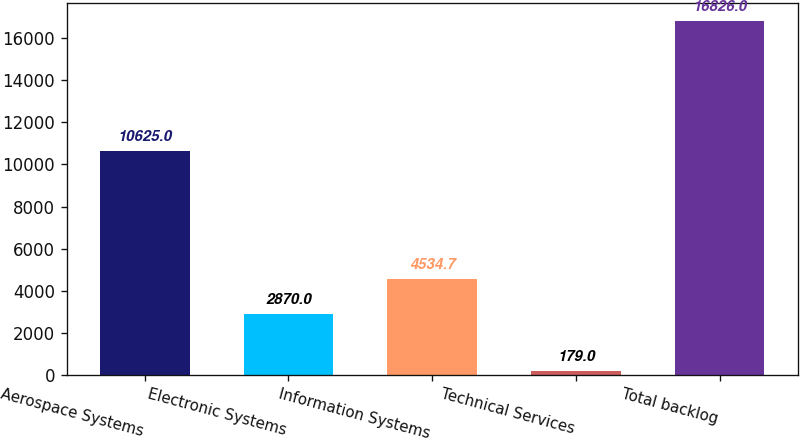Convert chart to OTSL. <chart><loc_0><loc_0><loc_500><loc_500><bar_chart><fcel>Aerospace Systems<fcel>Electronic Systems<fcel>Information Systems<fcel>Technical Services<fcel>Total backlog<nl><fcel>10625<fcel>2870<fcel>4534.7<fcel>179<fcel>16826<nl></chart> 